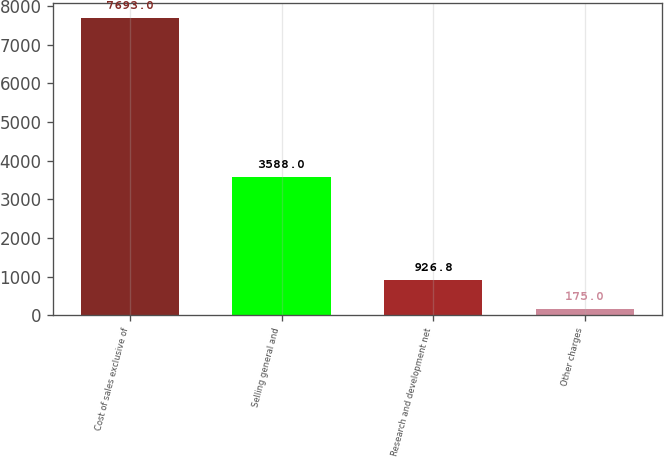Convert chart. <chart><loc_0><loc_0><loc_500><loc_500><bar_chart><fcel>Cost of sales exclusive of<fcel>Selling general and<fcel>Research and development net<fcel>Other charges<nl><fcel>7693<fcel>3588<fcel>926.8<fcel>175<nl></chart> 